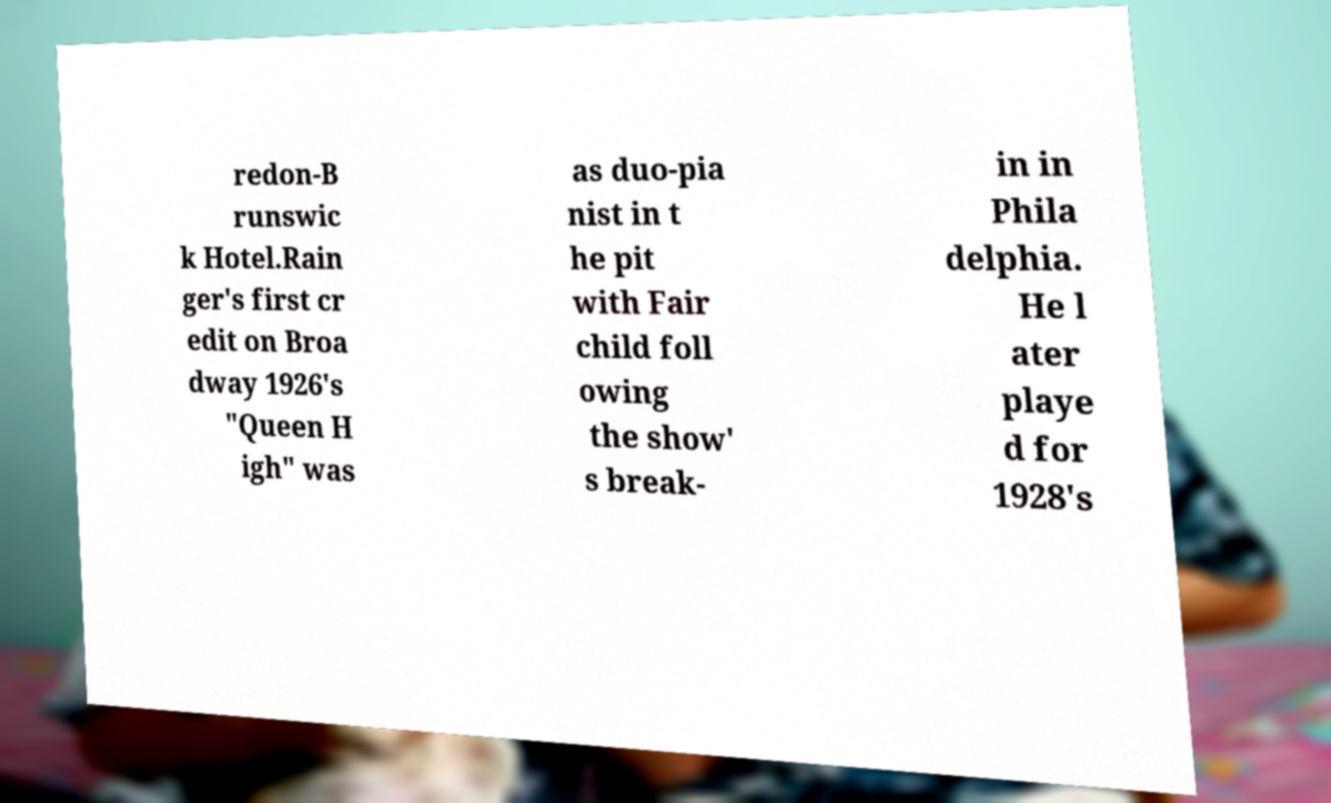Can you read and provide the text displayed in the image?This photo seems to have some interesting text. Can you extract and type it out for me? redon-B runswic k Hotel.Rain ger's first cr edit on Broa dway 1926's "Queen H igh" was as duo-pia nist in t he pit with Fair child foll owing the show' s break- in in Phila delphia. He l ater playe d for 1928's 